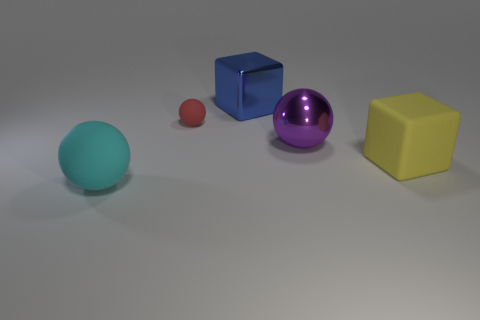There is a big matte thing that is in front of the big cube to the right of the big blue thing; is there a tiny rubber sphere in front of it?
Ensure brevity in your answer.  No. What number of other objects are the same size as the blue metallic block?
Give a very brief answer. 3. There is a yellow rubber cube; are there any large purple shiny things in front of it?
Keep it short and to the point. No. Do the tiny object and the matte thing that is right of the purple shiny thing have the same color?
Give a very brief answer. No. What color is the large rubber object that is to the right of the large sphere behind the cyan rubber sphere that is in front of the tiny object?
Provide a short and direct response. Yellow. Is there another object of the same shape as the large yellow object?
Your answer should be compact. Yes. The shiny ball that is the same size as the yellow cube is what color?
Ensure brevity in your answer.  Purple. What material is the block behind the purple shiny ball?
Keep it short and to the point. Metal. Do the big matte object that is behind the cyan sphere and the thing that is behind the tiny rubber object have the same shape?
Offer a very short reply. Yes. Are there the same number of cyan spheres behind the matte block and large yellow rubber objects?
Give a very brief answer. No. 